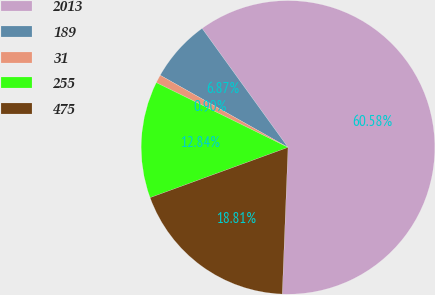<chart> <loc_0><loc_0><loc_500><loc_500><pie_chart><fcel>2013<fcel>189<fcel>31<fcel>255<fcel>475<nl><fcel>60.58%<fcel>6.87%<fcel>0.9%<fcel>12.84%<fcel>18.81%<nl></chart> 